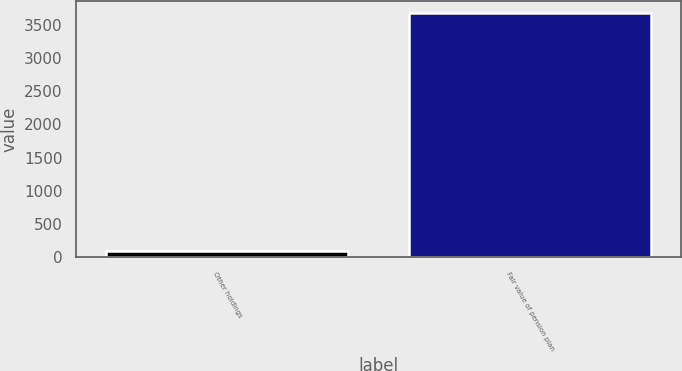<chart> <loc_0><loc_0><loc_500><loc_500><bar_chart><fcel>Other holdings<fcel>Fair value of pension plan<nl><fcel>96<fcel>3673<nl></chart> 